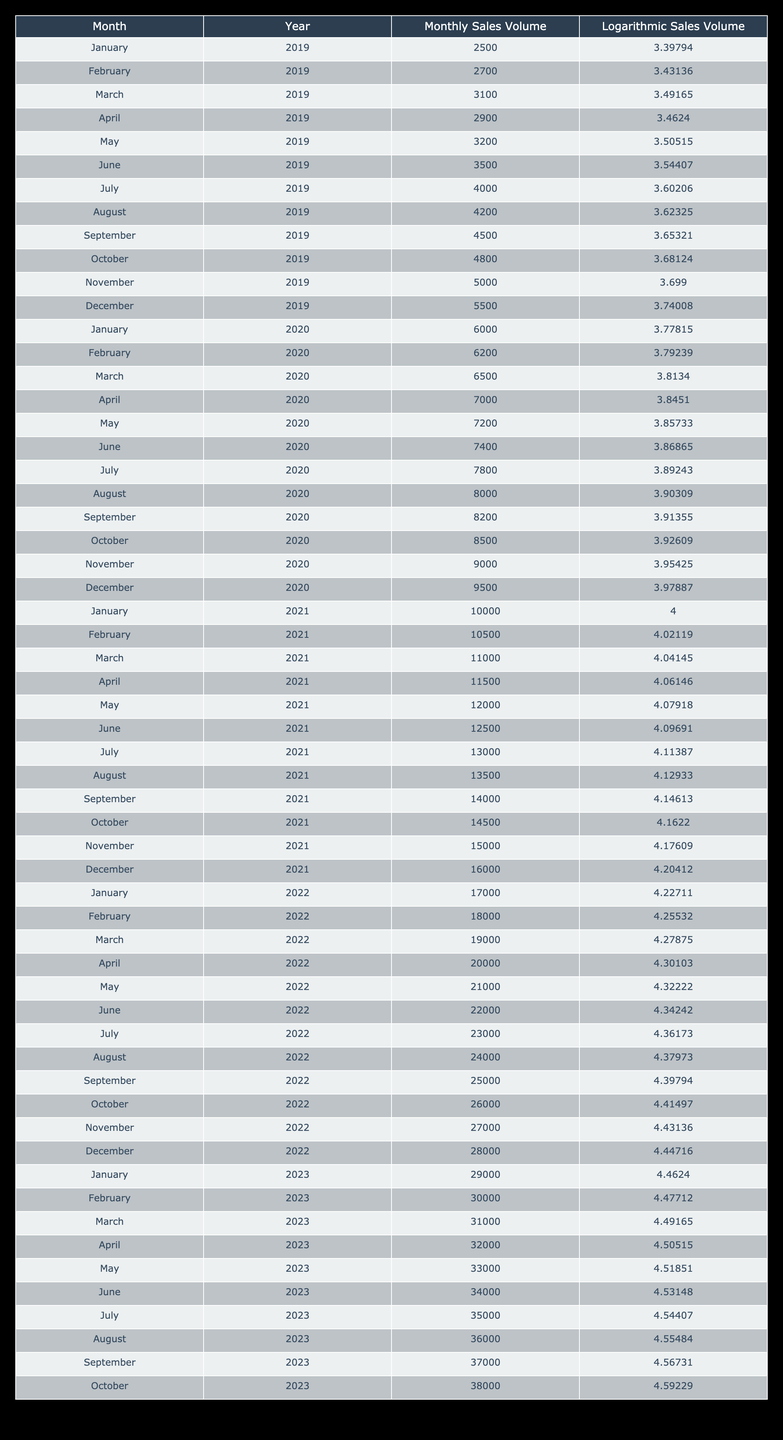What was the monthly sales volume in December 2020? Looking at the 'Monthly Sales Volume' column in the table for December 2020, the value present is 9500.
Answer: 9500 During which month in 2021 was the sales volume the highest? By scanning the table, December 2021 has the highest sales volume listed at 16000.
Answer: December 2021 What is the average monthly sales volume for 2022? The sales volumes for 2022 are 17000, 18000, 19000, 20000, 21000, 22000, 23000, 24000, 25000, 26000, 27000, and 28000. Summing these gives 282000, and dividing by 12 yields an average of 23500.
Answer: 23500 Was the monthly sales volume in November 2022 lower than in January 2023? In November 2022, the sales volume is listed as 27000, while in January 2023, it is 29000. Since 27000 is less than 29000, the answer is yes.
Answer: Yes How much did the monthly sales volume increase from March 2021 to April 2021? The sales volume in March 2021 is 11000 and in April 2021 is 11500. The increase is calculated by subtracting March's volume from April's: 11500 - 11000 = 500.
Answer: 500 What is the total sales volume recorded in July 2023? The 'Monthly Sales Volume' for July 2023 is stated as 35000. This is a direct reference from the table.
Answer: 35000 Which has a higher logarithmic sales volume, January 2022 or January 2023? January 2022 has a logarithmic value of 4.22711, while January 2023 has a logarithmic value of 4.4624. Since 4.4624 is greater, January 2023 has a higher logarithmic sales volume.
Answer: January 2023 What is the difference in logarithmic sales volume between December 2021 and December 2022? December 2021 has a logarithmic volume of 4.20412 and December 2022 has 4.44716. The difference is 4.44716 - 4.20412 = 0.24304.
Answer: 0.24304 Which month in 2020 saw a sales volume of 8000? The sales volume of 8000 can be found in August 2020, which is clearly listed in the table.
Answer: August 2020 